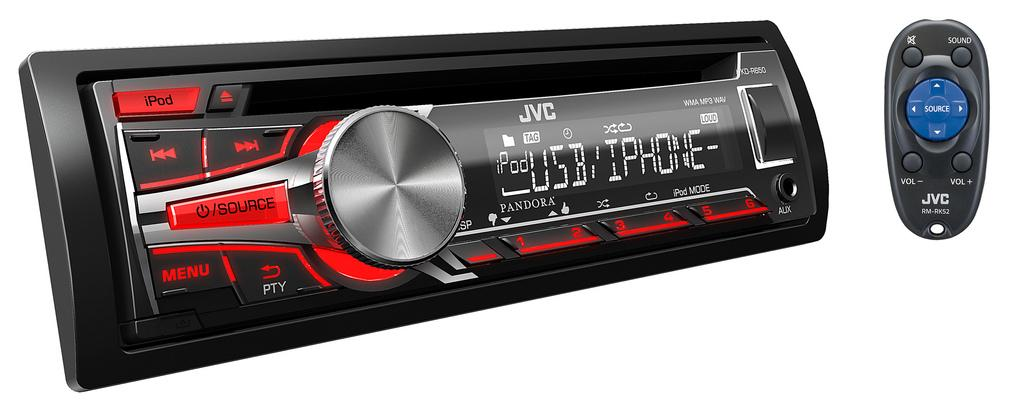Provide a one-sentence caption for the provided image. A car radio player with an iPod plugged in with USB/iPhone features. 